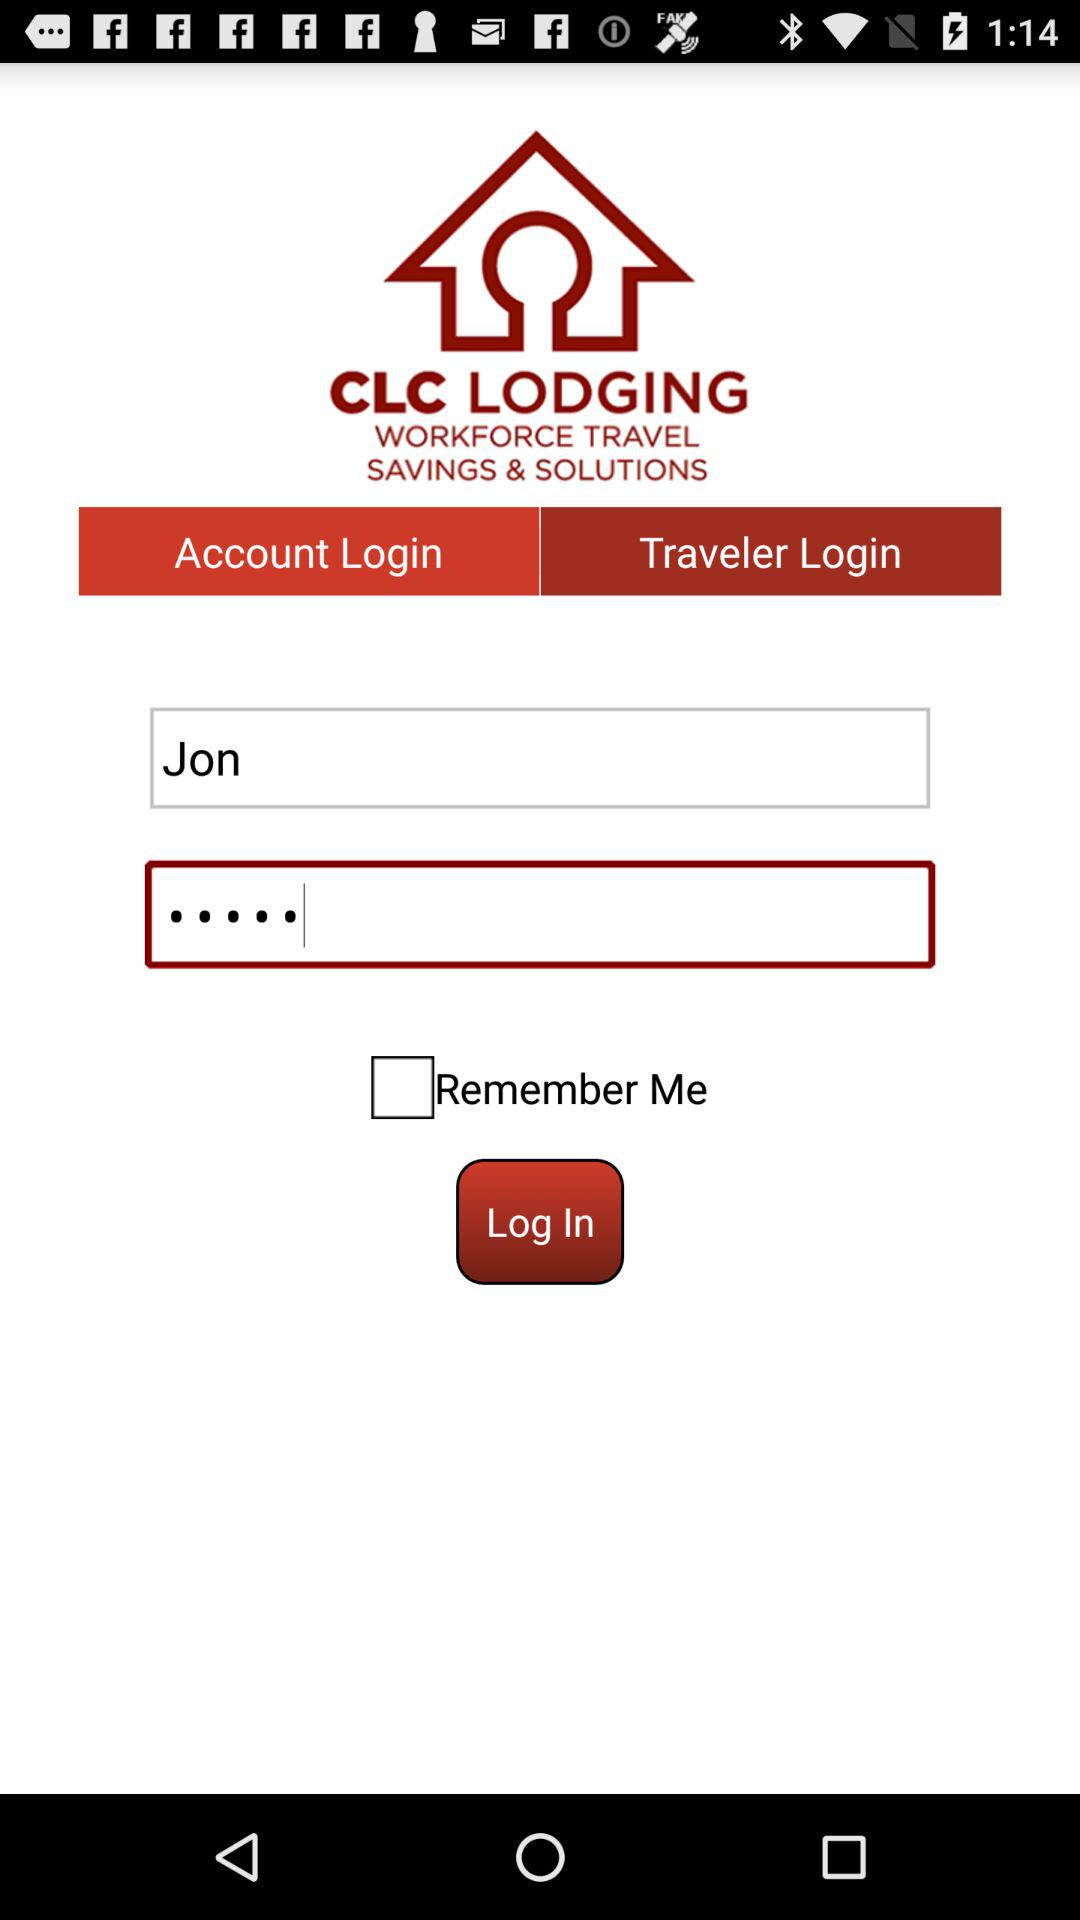What is the status of "Remember Me"? The status of "Remember Me" is "off". 